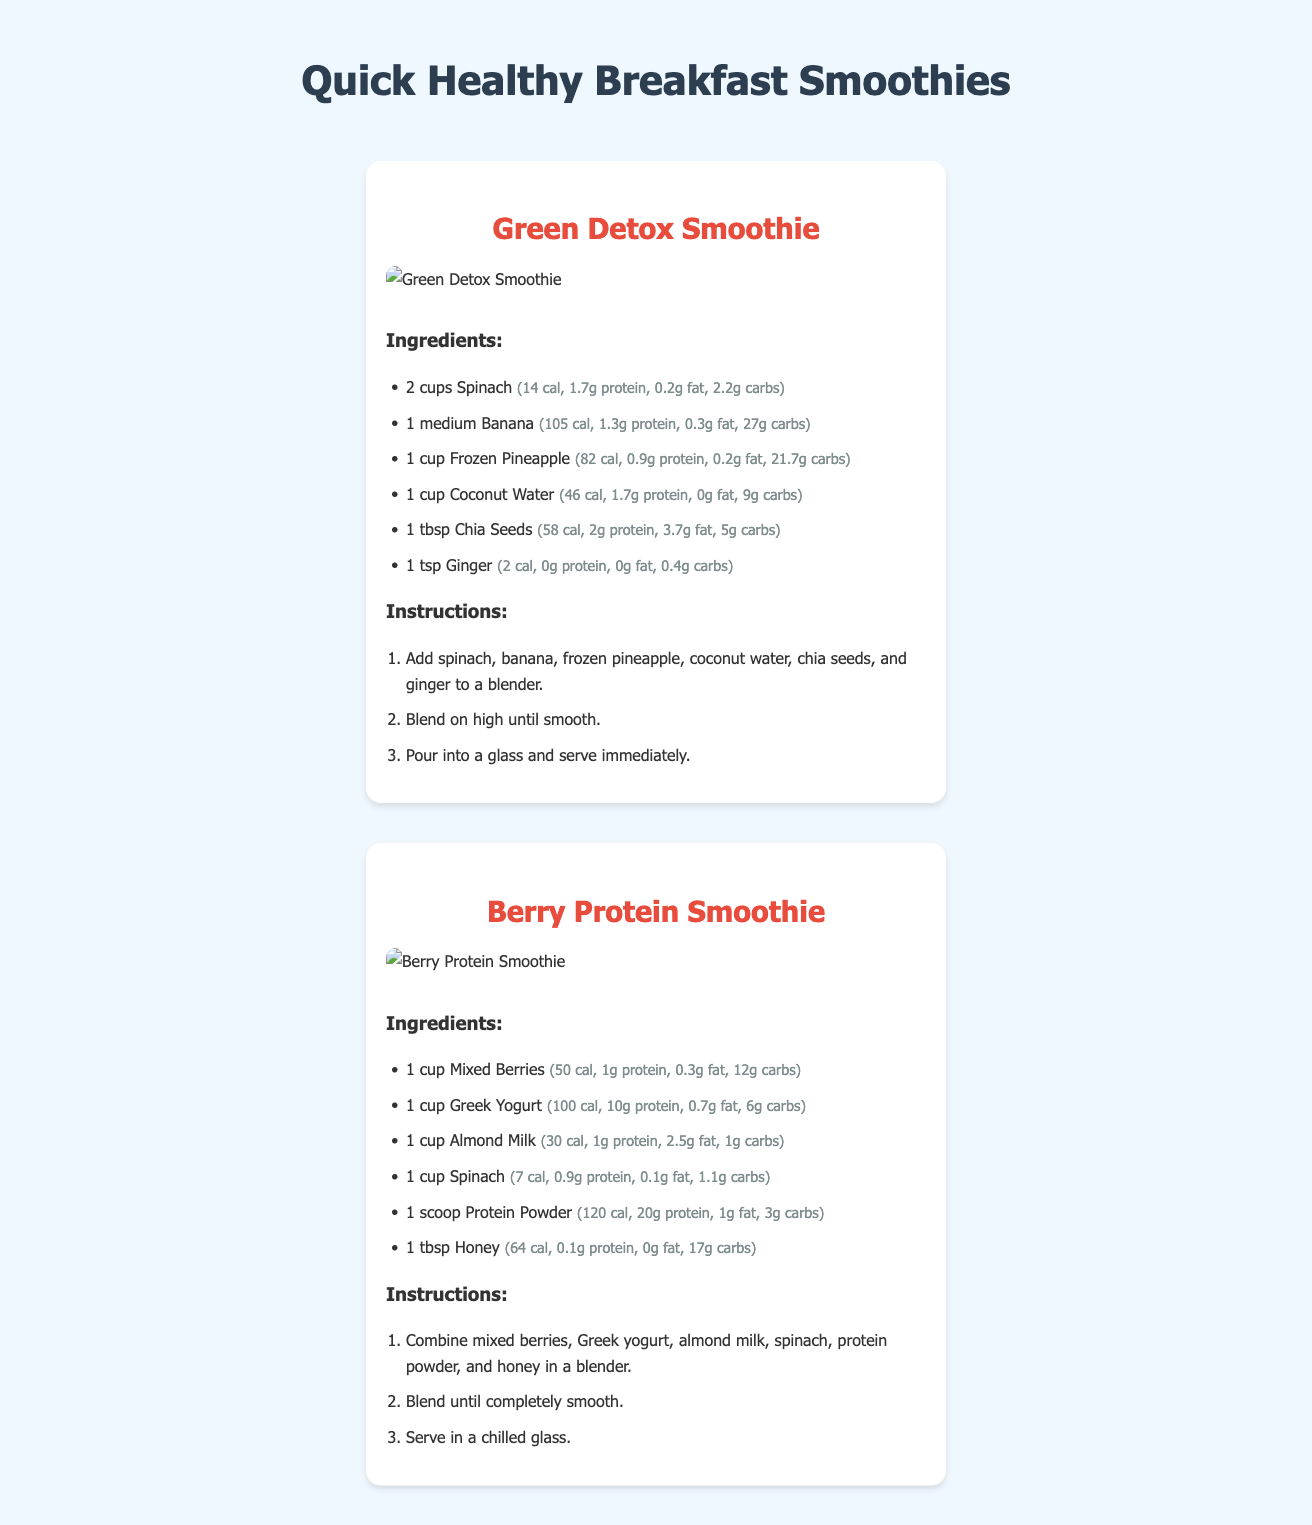What is the title of the document? The title of the document is indicated at the top of the page, which is "Quick Healthy Breakfast Smoothies."
Answer: Quick Healthy Breakfast Smoothies How many cups of spinach are used in the Green Detox Smoothie? The ingredient list shows that 2 cups of spinach are needed for the Green Detox Smoothie.
Answer: 2 cups What is the calorie count of the Berry Protein Smoothie? The calorie count for the Berry Protein Smoothie can be calculated by adding the calorie values of all ingredients, which totals to 364 calories.
Answer: 364 cal Which smoothie contains coconut water? The Green Detox Smoothie ingredient list includes coconut water.
Answer: Green Detox Smoothie How many steps are in the preparation instructions for the Berry Protein Smoothie? The preparation instructions for the Berry Protein Smoothie consist of 3 steps listed in an ordered format.
Answer: 3 steps What ingredient is common to both smoothies? The ingredient list of both smoothies shows that spinach is used in each recipe.
Answer: Spinach What is the main purpose of this document? The document serves to provide recipes for quick and healthy breakfast smoothies, along with their ingredients and preparation instructions.
Answer: To provide recipes What is a unique feature of the smoothie cards? A unique feature is the vibrant images of each smoothie displayed alongside the recipe information.
Answer: Vibrant images What type of milk is used in the Berry Protein Smoothie? The Berry Protein Smoothie recipe includes almond milk.
Answer: Almond Milk 